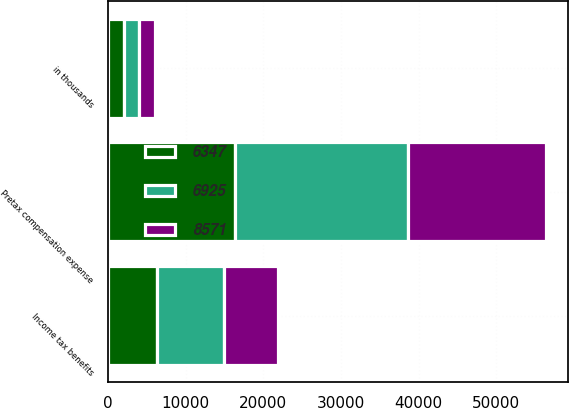Convert chart. <chart><loc_0><loc_0><loc_500><loc_500><stacked_bar_chart><ecel><fcel>in thousands<fcel>Pretax compensation expense<fcel>Income tax benefits<nl><fcel>8571<fcel>2016<fcel>17823<fcel>6925<nl><fcel>6347<fcel>2015<fcel>16362<fcel>6347<nl><fcel>6925<fcel>2014<fcel>22217<fcel>8571<nl></chart> 